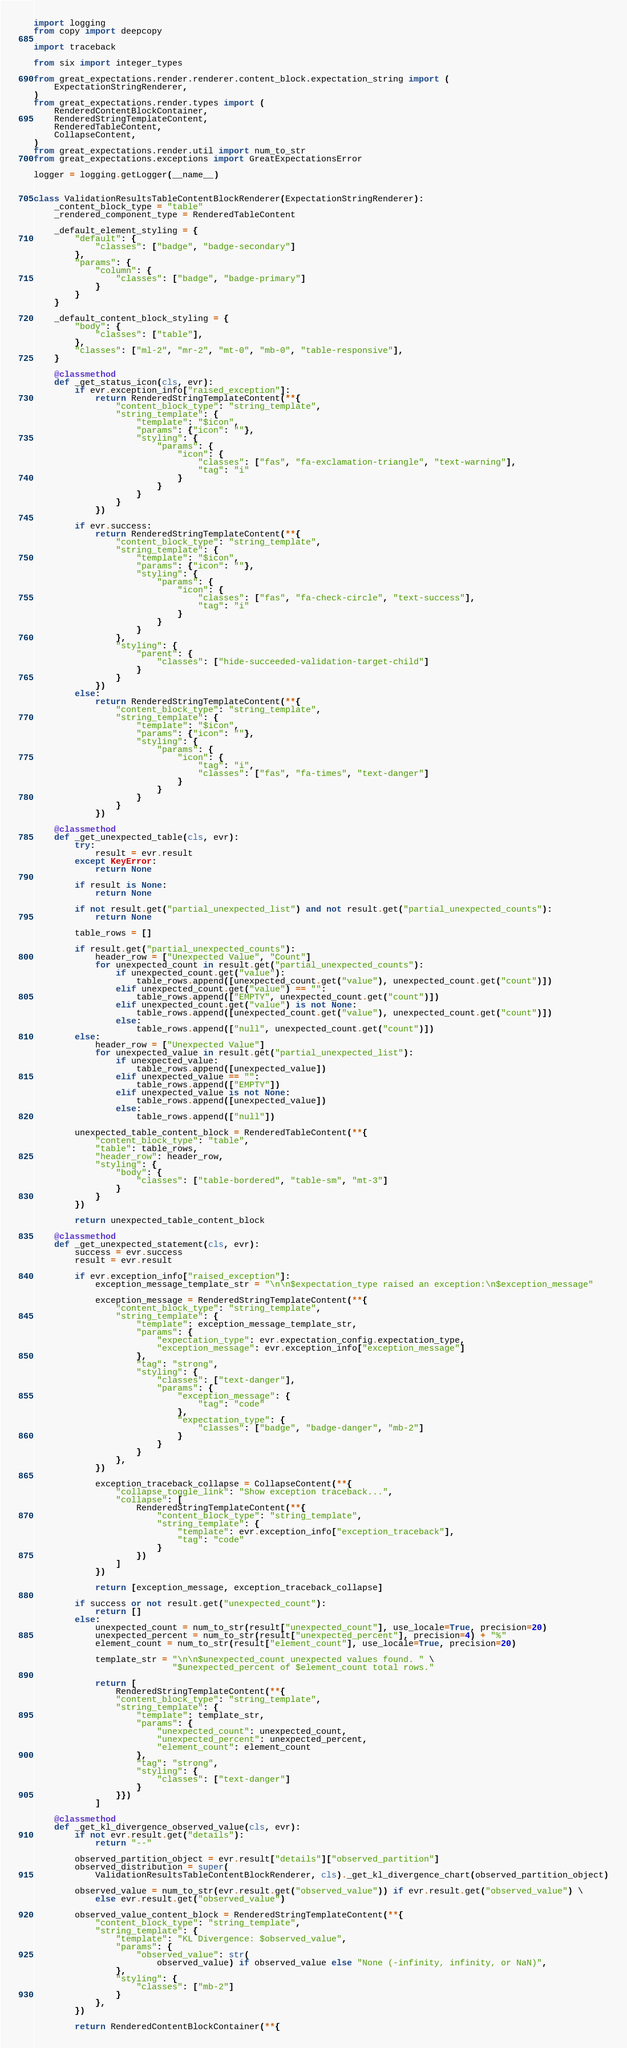Convert code to text. <code><loc_0><loc_0><loc_500><loc_500><_Python_>import logging
from copy import deepcopy

import traceback

from six import integer_types

from great_expectations.render.renderer.content_block.expectation_string import (
    ExpectationStringRenderer,
)
from great_expectations.render.types import (
    RenderedContentBlockContainer,
    RenderedStringTemplateContent,
    RenderedTableContent,
    CollapseContent,
)
from great_expectations.render.util import num_to_str
from great_expectations.exceptions import GreatExpectationsError

logger = logging.getLogger(__name__)


class ValidationResultsTableContentBlockRenderer(ExpectationStringRenderer):
    _content_block_type = "table"
    _rendered_component_type = RenderedTableContent

    _default_element_styling = {
        "default": {
            "classes": ["badge", "badge-secondary"]
        },
        "params": {
            "column": {
                "classes": ["badge", "badge-primary"]
            }
        }
    }

    _default_content_block_styling = {
        "body": {
            "classes": ["table"],
        },
        "classes": ["ml-2", "mr-2", "mt-0", "mb-0", "table-responsive"],
    }

    @classmethod
    def _get_status_icon(cls, evr):
        if evr.exception_info["raised_exception"]:
            return RenderedStringTemplateContent(**{
                "content_block_type": "string_template",
                "string_template": {
                    "template": "$icon",
                    "params": {"icon": ""},
                    "styling": {
                        "params": {
                            "icon": {
                                "classes": ["fas", "fa-exclamation-triangle", "text-warning"],
                                "tag": "i"
                            }
                        }
                    }
                }
            })

        if evr.success:
            return RenderedStringTemplateContent(**{
                "content_block_type": "string_template",
                "string_template": {
                    "template": "$icon",
                    "params": {"icon": ""},
                    "styling": {
                        "params": {
                            "icon": {
                                "classes": ["fas", "fa-check-circle", "text-success"],
                                "tag": "i"
                            }
                        }
                    }
                },
                "styling": {
                    "parent": {
                        "classes": ["hide-succeeded-validation-target-child"]
                    }
                }
            })
        else:
            return RenderedStringTemplateContent(**{
                "content_block_type": "string_template",
                "string_template": {
                    "template": "$icon",
                    "params": {"icon": ""},
                    "styling": {
                        "params": {
                            "icon": {
                                "tag": "i",
                                "classes": ["fas", "fa-times", "text-danger"]
                            }
                        }
                    }
                }
            })

    @classmethod
    def _get_unexpected_table(cls, evr):
        try:
            result = evr.result
        except KeyError:
            return None

        if result is None:
            return None

        if not result.get("partial_unexpected_list") and not result.get("partial_unexpected_counts"):
            return None

        table_rows = []

        if result.get("partial_unexpected_counts"):
            header_row = ["Unexpected Value", "Count"]
            for unexpected_count in result.get("partial_unexpected_counts"):
                if unexpected_count.get("value"):
                    table_rows.append([unexpected_count.get("value"), unexpected_count.get("count")])
                elif unexpected_count.get("value") == "":
                    table_rows.append(["EMPTY", unexpected_count.get("count")])
                elif unexpected_count.get("value") is not None:
                    table_rows.append([unexpected_count.get("value"), unexpected_count.get("count")])
                else:
                    table_rows.append(["null", unexpected_count.get("count")])
        else:
            header_row = ["Unexpected Value"]
            for unexpected_value in result.get("partial_unexpected_list"):
                if unexpected_value:
                    table_rows.append([unexpected_value])
                elif unexpected_value == "":
                    table_rows.append(["EMPTY"])
                elif unexpected_value is not None:
                    table_rows.append([unexpected_value])
                else:
                    table_rows.append(["null"])

        unexpected_table_content_block = RenderedTableContent(**{
            "content_block_type": "table",
            "table": table_rows,
            "header_row": header_row,
            "styling": {
                "body": {
                    "classes": ["table-bordered", "table-sm", "mt-3"]
                }
            }
        })

        return unexpected_table_content_block

    @classmethod
    def _get_unexpected_statement(cls, evr):
        success = evr.success
        result = evr.result

        if evr.exception_info["raised_exception"]:
            exception_message_template_str = "\n\n$expectation_type raised an exception:\n$exception_message"

            exception_message = RenderedStringTemplateContent(**{
                "content_block_type": "string_template",
                "string_template": {
                    "template": exception_message_template_str,
                    "params": {
                        "expectation_type": evr.expectation_config.expectation_type,
                        "exception_message": evr.exception_info["exception_message"]
                    },
                    "tag": "strong",
                    "styling": {
                        "classes": ["text-danger"],
                        "params": {
                            "exception_message": {
                                "tag": "code"
                            },
                            "expectation_type": {
                                "classes": ["badge", "badge-danger", "mb-2"]
                            }
                        }
                    }
                },
            })

            exception_traceback_collapse = CollapseContent(**{
                "collapse_toggle_link": "Show exception traceback...",
                "collapse": [
                    RenderedStringTemplateContent(**{
                        "content_block_type": "string_template",
                        "string_template": {
                            "template": evr.exception_info["exception_traceback"],
                            "tag": "code"
                        }
                    })
                ]
            })

            return [exception_message, exception_traceback_collapse]

        if success or not result.get("unexpected_count"):
            return []
        else:
            unexpected_count = num_to_str(result["unexpected_count"], use_locale=True, precision=20)
            unexpected_percent = num_to_str(result["unexpected_percent"], precision=4) + "%"
            element_count = num_to_str(result["element_count"], use_locale=True, precision=20)

            template_str = "\n\n$unexpected_count unexpected values found. " \
                           "$unexpected_percent of $element_count total rows."

            return [
                RenderedStringTemplateContent(**{
                "content_block_type": "string_template",
                "string_template": {
                    "template": template_str,
                    "params": {
                        "unexpected_count": unexpected_count,
                        "unexpected_percent": unexpected_percent,
                        "element_count": element_count
                    },
                    "tag": "strong",
                    "styling": {
                        "classes": ["text-danger"]
                    }
                }})
            ]

    @classmethod
    def _get_kl_divergence_observed_value(cls, evr):
        if not evr.result.get("details"):
            return "--"

        observed_partition_object = evr.result["details"]["observed_partition"]
        observed_distribution = super(
            ValidationResultsTableContentBlockRenderer, cls)._get_kl_divergence_chart(observed_partition_object)

        observed_value = num_to_str(evr.result.get("observed_value")) if evr.result.get("observed_value") \
            else evr.result.get("observed_value")

        observed_value_content_block = RenderedStringTemplateContent(**{
            "content_block_type": "string_template",
            "string_template": {
                "template": "KL Divergence: $observed_value",
                "params": {
                    "observed_value": str(
                        observed_value) if observed_value else "None (-infinity, infinity, or NaN)",
                },
                "styling": {
                    "classes": ["mb-2"]
                }
            },
        })

        return RenderedContentBlockContainer(**{</code> 